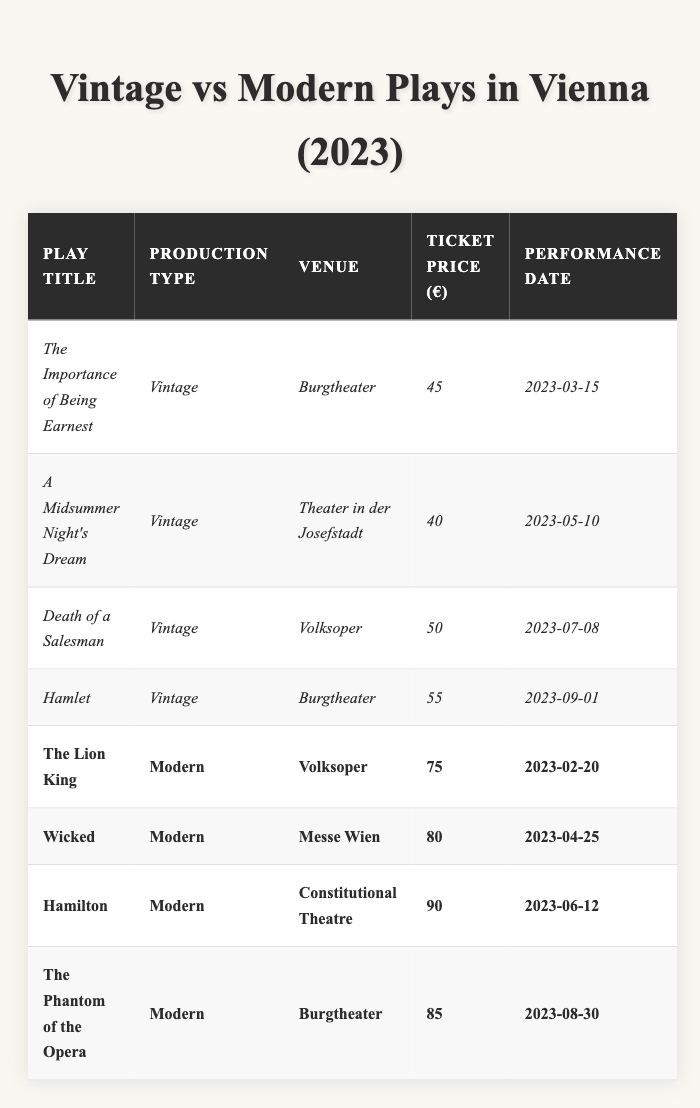What is the ticket price for "Hamlet"? The table shows that the ticket price for "Hamlet," a vintage production at the Burgtheater, is €55.
Answer: €55 What venue is hosting "A Midsummer Night's Dream"? The table lists "A Midsummer Night's Dream" as a vintage production, and it is being held at the Theater in der Josefstadt.
Answer: Theater in der Josefstadt Which modern play has the highest ticket price? To find the highest ticket price among the modern plays, we can compare the values: The Lion King (€75), Wicked (€80), Hamilton (€90), and The Phantom of the Opera (€85). Hamilton has the highest price of €90.
Answer: €90 How many vintage plays are listed in the table? By counting, we can see that there are four vintage plays listed in the table: The Importance of Being Earnest, A Midsummer Night's Dream, Death of a Salesman, and Hamlet.
Answer: 4 What is the average ticket price for vintage plays? The ticket prices for the vintage plays are €45, €40, €50, and €55. Summing these gives 45 + 40 + 50 + 55 = 190. Dividing by 4 (the number of vintage plays) gives an average of €47.50.
Answer: €47.50 Is "The Lion King" a vintage or modern play? According to the table, "The Lion King" is classified as a modern play.
Answer: Modern What is the difference in ticket prices between the most expensive modern play and the least expensive vintage play? The most expensive modern play is "Hamilton" at €90, and the least expensive vintage play is "A Midsummer Night's Dream" at €40. The difference is 90 - 40 = €50.
Answer: €50 Which vintage play has the earliest performance date? Looking at the performance dates for vintage plays, "The Importance of Being Earnest" on 2023-03-15 is the earliest among the listed dates.
Answer: The Importance of Being Earnest What percentage of plays listed are vintage? There are 4 vintage plays and 4 modern plays, totaling 8 plays. The percentage of vintage plays is (4/8) * 100 = 50%.
Answer: 50% Does the table show any modern plays performed at the Burgtheater? The table indicates that "The Phantom of the Opera," a modern play, is performed at the Burgtheater. Therefore, the answer is yes.
Answer: Yes 